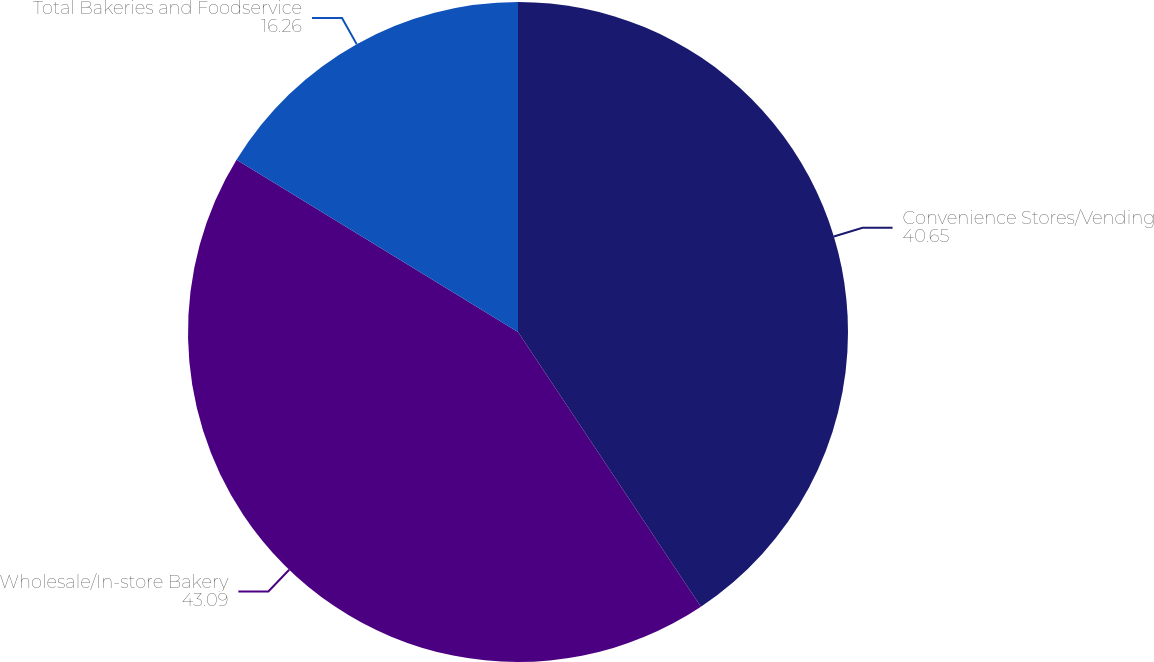Convert chart. <chart><loc_0><loc_0><loc_500><loc_500><pie_chart><fcel>Convenience Stores/Vending<fcel>Wholesale/In-store Bakery<fcel>Total Bakeries and Foodservice<nl><fcel>40.65%<fcel>43.09%<fcel>16.26%<nl></chart> 